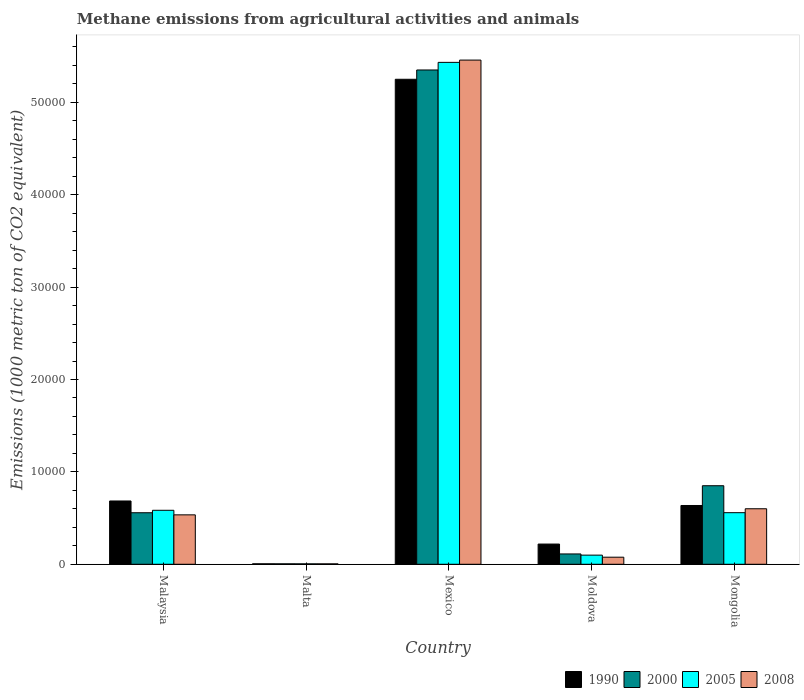Are the number of bars per tick equal to the number of legend labels?
Your answer should be very brief. Yes. Are the number of bars on each tick of the X-axis equal?
Your response must be concise. Yes. What is the label of the 3rd group of bars from the left?
Make the answer very short. Mexico. In how many cases, is the number of bars for a given country not equal to the number of legend labels?
Your response must be concise. 0. What is the amount of methane emitted in 2005 in Malaysia?
Offer a very short reply. 5844. Across all countries, what is the maximum amount of methane emitted in 2008?
Your answer should be compact. 5.46e+04. Across all countries, what is the minimum amount of methane emitted in 2005?
Offer a terse response. 48.2. In which country was the amount of methane emitted in 2005 minimum?
Your response must be concise. Malta. What is the total amount of methane emitted in 1990 in the graph?
Make the answer very short. 6.80e+04. What is the difference between the amount of methane emitted in 1990 in Mexico and that in Moldova?
Offer a very short reply. 5.03e+04. What is the difference between the amount of methane emitted in 2008 in Malaysia and the amount of methane emitted in 2005 in Moldova?
Ensure brevity in your answer.  4360. What is the average amount of methane emitted in 1990 per country?
Your answer should be compact. 1.36e+04. What is the difference between the amount of methane emitted of/in 2008 and amount of methane emitted of/in 2005 in Moldova?
Give a very brief answer. -223.2. What is the ratio of the amount of methane emitted in 2005 in Moldova to that in Mongolia?
Your response must be concise. 0.18. Is the amount of methane emitted in 2008 in Malta less than that in Mexico?
Ensure brevity in your answer.  Yes. What is the difference between the highest and the second highest amount of methane emitted in 2000?
Provide a short and direct response. 4.79e+04. What is the difference between the highest and the lowest amount of methane emitted in 2008?
Offer a terse response. 5.45e+04. Is the sum of the amount of methane emitted in 2005 in Mexico and Moldova greater than the maximum amount of methane emitted in 2000 across all countries?
Give a very brief answer. Yes. What does the 4th bar from the left in Malaysia represents?
Make the answer very short. 2008. Is it the case that in every country, the sum of the amount of methane emitted in 2000 and amount of methane emitted in 2008 is greater than the amount of methane emitted in 1990?
Give a very brief answer. No. Are the values on the major ticks of Y-axis written in scientific E-notation?
Offer a terse response. No. Does the graph contain any zero values?
Offer a terse response. No. Does the graph contain grids?
Your response must be concise. No. How many legend labels are there?
Provide a short and direct response. 4. What is the title of the graph?
Ensure brevity in your answer.  Methane emissions from agricultural activities and animals. What is the label or title of the X-axis?
Your answer should be compact. Country. What is the label or title of the Y-axis?
Ensure brevity in your answer.  Emissions (1000 metric ton of CO2 equivalent). What is the Emissions (1000 metric ton of CO2 equivalent) of 1990 in Malaysia?
Keep it short and to the point. 6851.5. What is the Emissions (1000 metric ton of CO2 equivalent) of 2000 in Malaysia?
Provide a short and direct response. 5579.2. What is the Emissions (1000 metric ton of CO2 equivalent) of 2005 in Malaysia?
Give a very brief answer. 5844. What is the Emissions (1000 metric ton of CO2 equivalent) of 2008 in Malaysia?
Keep it short and to the point. 5350.3. What is the Emissions (1000 metric ton of CO2 equivalent) in 1990 in Malta?
Offer a terse response. 50.9. What is the Emissions (1000 metric ton of CO2 equivalent) in 2000 in Malta?
Give a very brief answer. 50.6. What is the Emissions (1000 metric ton of CO2 equivalent) in 2005 in Malta?
Your response must be concise. 48.2. What is the Emissions (1000 metric ton of CO2 equivalent) of 2008 in Malta?
Your answer should be compact. 46.9. What is the Emissions (1000 metric ton of CO2 equivalent) of 1990 in Mexico?
Your answer should be compact. 5.25e+04. What is the Emissions (1000 metric ton of CO2 equivalent) in 2000 in Mexico?
Give a very brief answer. 5.35e+04. What is the Emissions (1000 metric ton of CO2 equivalent) in 2005 in Mexico?
Keep it short and to the point. 5.43e+04. What is the Emissions (1000 metric ton of CO2 equivalent) in 2008 in Mexico?
Your answer should be very brief. 5.46e+04. What is the Emissions (1000 metric ton of CO2 equivalent) in 1990 in Moldova?
Your answer should be compact. 2188.8. What is the Emissions (1000 metric ton of CO2 equivalent) in 2000 in Moldova?
Provide a succinct answer. 1119.3. What is the Emissions (1000 metric ton of CO2 equivalent) of 2005 in Moldova?
Make the answer very short. 990.3. What is the Emissions (1000 metric ton of CO2 equivalent) of 2008 in Moldova?
Offer a terse response. 767.1. What is the Emissions (1000 metric ton of CO2 equivalent) in 1990 in Mongolia?
Provide a succinct answer. 6363.5. What is the Emissions (1000 metric ton of CO2 equivalent) of 2000 in Mongolia?
Keep it short and to the point. 8502.3. What is the Emissions (1000 metric ton of CO2 equivalent) of 2005 in Mongolia?
Offer a very short reply. 5584.9. What is the Emissions (1000 metric ton of CO2 equivalent) in 2008 in Mongolia?
Your response must be concise. 6009.3. Across all countries, what is the maximum Emissions (1000 metric ton of CO2 equivalent) in 1990?
Offer a terse response. 5.25e+04. Across all countries, what is the maximum Emissions (1000 metric ton of CO2 equivalent) in 2000?
Offer a terse response. 5.35e+04. Across all countries, what is the maximum Emissions (1000 metric ton of CO2 equivalent) in 2005?
Your answer should be very brief. 5.43e+04. Across all countries, what is the maximum Emissions (1000 metric ton of CO2 equivalent) of 2008?
Your answer should be very brief. 5.46e+04. Across all countries, what is the minimum Emissions (1000 metric ton of CO2 equivalent) of 1990?
Provide a short and direct response. 50.9. Across all countries, what is the minimum Emissions (1000 metric ton of CO2 equivalent) of 2000?
Offer a very short reply. 50.6. Across all countries, what is the minimum Emissions (1000 metric ton of CO2 equivalent) in 2005?
Your response must be concise. 48.2. Across all countries, what is the minimum Emissions (1000 metric ton of CO2 equivalent) in 2008?
Make the answer very short. 46.9. What is the total Emissions (1000 metric ton of CO2 equivalent) of 1990 in the graph?
Provide a short and direct response. 6.80e+04. What is the total Emissions (1000 metric ton of CO2 equivalent) of 2000 in the graph?
Your response must be concise. 6.88e+04. What is the total Emissions (1000 metric ton of CO2 equivalent) in 2005 in the graph?
Make the answer very short. 6.68e+04. What is the total Emissions (1000 metric ton of CO2 equivalent) of 2008 in the graph?
Provide a short and direct response. 6.67e+04. What is the difference between the Emissions (1000 metric ton of CO2 equivalent) in 1990 in Malaysia and that in Malta?
Make the answer very short. 6800.6. What is the difference between the Emissions (1000 metric ton of CO2 equivalent) of 2000 in Malaysia and that in Malta?
Make the answer very short. 5528.6. What is the difference between the Emissions (1000 metric ton of CO2 equivalent) in 2005 in Malaysia and that in Malta?
Provide a short and direct response. 5795.8. What is the difference between the Emissions (1000 metric ton of CO2 equivalent) in 2008 in Malaysia and that in Malta?
Offer a terse response. 5303.4. What is the difference between the Emissions (1000 metric ton of CO2 equivalent) of 1990 in Malaysia and that in Mexico?
Offer a terse response. -4.56e+04. What is the difference between the Emissions (1000 metric ton of CO2 equivalent) of 2000 in Malaysia and that in Mexico?
Give a very brief answer. -4.79e+04. What is the difference between the Emissions (1000 metric ton of CO2 equivalent) in 2005 in Malaysia and that in Mexico?
Ensure brevity in your answer.  -4.85e+04. What is the difference between the Emissions (1000 metric ton of CO2 equivalent) of 2008 in Malaysia and that in Mexico?
Offer a very short reply. -4.92e+04. What is the difference between the Emissions (1000 metric ton of CO2 equivalent) of 1990 in Malaysia and that in Moldova?
Provide a short and direct response. 4662.7. What is the difference between the Emissions (1000 metric ton of CO2 equivalent) in 2000 in Malaysia and that in Moldova?
Offer a very short reply. 4459.9. What is the difference between the Emissions (1000 metric ton of CO2 equivalent) in 2005 in Malaysia and that in Moldova?
Keep it short and to the point. 4853.7. What is the difference between the Emissions (1000 metric ton of CO2 equivalent) in 2008 in Malaysia and that in Moldova?
Give a very brief answer. 4583.2. What is the difference between the Emissions (1000 metric ton of CO2 equivalent) of 1990 in Malaysia and that in Mongolia?
Provide a succinct answer. 488. What is the difference between the Emissions (1000 metric ton of CO2 equivalent) of 2000 in Malaysia and that in Mongolia?
Offer a terse response. -2923.1. What is the difference between the Emissions (1000 metric ton of CO2 equivalent) of 2005 in Malaysia and that in Mongolia?
Your answer should be very brief. 259.1. What is the difference between the Emissions (1000 metric ton of CO2 equivalent) in 2008 in Malaysia and that in Mongolia?
Ensure brevity in your answer.  -659. What is the difference between the Emissions (1000 metric ton of CO2 equivalent) of 1990 in Malta and that in Mexico?
Keep it short and to the point. -5.24e+04. What is the difference between the Emissions (1000 metric ton of CO2 equivalent) of 2000 in Malta and that in Mexico?
Ensure brevity in your answer.  -5.35e+04. What is the difference between the Emissions (1000 metric ton of CO2 equivalent) of 2005 in Malta and that in Mexico?
Make the answer very short. -5.43e+04. What is the difference between the Emissions (1000 metric ton of CO2 equivalent) in 2008 in Malta and that in Mexico?
Offer a very short reply. -5.45e+04. What is the difference between the Emissions (1000 metric ton of CO2 equivalent) in 1990 in Malta and that in Moldova?
Make the answer very short. -2137.9. What is the difference between the Emissions (1000 metric ton of CO2 equivalent) of 2000 in Malta and that in Moldova?
Offer a terse response. -1068.7. What is the difference between the Emissions (1000 metric ton of CO2 equivalent) of 2005 in Malta and that in Moldova?
Provide a succinct answer. -942.1. What is the difference between the Emissions (1000 metric ton of CO2 equivalent) of 2008 in Malta and that in Moldova?
Your answer should be very brief. -720.2. What is the difference between the Emissions (1000 metric ton of CO2 equivalent) in 1990 in Malta and that in Mongolia?
Ensure brevity in your answer.  -6312.6. What is the difference between the Emissions (1000 metric ton of CO2 equivalent) of 2000 in Malta and that in Mongolia?
Provide a short and direct response. -8451.7. What is the difference between the Emissions (1000 metric ton of CO2 equivalent) of 2005 in Malta and that in Mongolia?
Offer a terse response. -5536.7. What is the difference between the Emissions (1000 metric ton of CO2 equivalent) in 2008 in Malta and that in Mongolia?
Make the answer very short. -5962.4. What is the difference between the Emissions (1000 metric ton of CO2 equivalent) of 1990 in Mexico and that in Moldova?
Give a very brief answer. 5.03e+04. What is the difference between the Emissions (1000 metric ton of CO2 equivalent) in 2000 in Mexico and that in Moldova?
Offer a terse response. 5.24e+04. What is the difference between the Emissions (1000 metric ton of CO2 equivalent) of 2005 in Mexico and that in Moldova?
Provide a short and direct response. 5.33e+04. What is the difference between the Emissions (1000 metric ton of CO2 equivalent) in 2008 in Mexico and that in Moldova?
Provide a short and direct response. 5.38e+04. What is the difference between the Emissions (1000 metric ton of CO2 equivalent) of 1990 in Mexico and that in Mongolia?
Ensure brevity in your answer.  4.61e+04. What is the difference between the Emissions (1000 metric ton of CO2 equivalent) of 2000 in Mexico and that in Mongolia?
Your response must be concise. 4.50e+04. What is the difference between the Emissions (1000 metric ton of CO2 equivalent) of 2005 in Mexico and that in Mongolia?
Offer a terse response. 4.87e+04. What is the difference between the Emissions (1000 metric ton of CO2 equivalent) of 2008 in Mexico and that in Mongolia?
Your answer should be compact. 4.86e+04. What is the difference between the Emissions (1000 metric ton of CO2 equivalent) of 1990 in Moldova and that in Mongolia?
Make the answer very short. -4174.7. What is the difference between the Emissions (1000 metric ton of CO2 equivalent) of 2000 in Moldova and that in Mongolia?
Provide a short and direct response. -7383. What is the difference between the Emissions (1000 metric ton of CO2 equivalent) in 2005 in Moldova and that in Mongolia?
Make the answer very short. -4594.6. What is the difference between the Emissions (1000 metric ton of CO2 equivalent) in 2008 in Moldova and that in Mongolia?
Make the answer very short. -5242.2. What is the difference between the Emissions (1000 metric ton of CO2 equivalent) in 1990 in Malaysia and the Emissions (1000 metric ton of CO2 equivalent) in 2000 in Malta?
Offer a very short reply. 6800.9. What is the difference between the Emissions (1000 metric ton of CO2 equivalent) of 1990 in Malaysia and the Emissions (1000 metric ton of CO2 equivalent) of 2005 in Malta?
Offer a terse response. 6803.3. What is the difference between the Emissions (1000 metric ton of CO2 equivalent) of 1990 in Malaysia and the Emissions (1000 metric ton of CO2 equivalent) of 2008 in Malta?
Offer a very short reply. 6804.6. What is the difference between the Emissions (1000 metric ton of CO2 equivalent) in 2000 in Malaysia and the Emissions (1000 metric ton of CO2 equivalent) in 2005 in Malta?
Your answer should be very brief. 5531. What is the difference between the Emissions (1000 metric ton of CO2 equivalent) in 2000 in Malaysia and the Emissions (1000 metric ton of CO2 equivalent) in 2008 in Malta?
Your answer should be very brief. 5532.3. What is the difference between the Emissions (1000 metric ton of CO2 equivalent) in 2005 in Malaysia and the Emissions (1000 metric ton of CO2 equivalent) in 2008 in Malta?
Keep it short and to the point. 5797.1. What is the difference between the Emissions (1000 metric ton of CO2 equivalent) in 1990 in Malaysia and the Emissions (1000 metric ton of CO2 equivalent) in 2000 in Mexico?
Provide a succinct answer. -4.67e+04. What is the difference between the Emissions (1000 metric ton of CO2 equivalent) of 1990 in Malaysia and the Emissions (1000 metric ton of CO2 equivalent) of 2005 in Mexico?
Give a very brief answer. -4.75e+04. What is the difference between the Emissions (1000 metric ton of CO2 equivalent) of 1990 in Malaysia and the Emissions (1000 metric ton of CO2 equivalent) of 2008 in Mexico?
Your response must be concise. -4.77e+04. What is the difference between the Emissions (1000 metric ton of CO2 equivalent) of 2000 in Malaysia and the Emissions (1000 metric ton of CO2 equivalent) of 2005 in Mexico?
Your response must be concise. -4.88e+04. What is the difference between the Emissions (1000 metric ton of CO2 equivalent) in 2000 in Malaysia and the Emissions (1000 metric ton of CO2 equivalent) in 2008 in Mexico?
Keep it short and to the point. -4.90e+04. What is the difference between the Emissions (1000 metric ton of CO2 equivalent) of 2005 in Malaysia and the Emissions (1000 metric ton of CO2 equivalent) of 2008 in Mexico?
Give a very brief answer. -4.87e+04. What is the difference between the Emissions (1000 metric ton of CO2 equivalent) in 1990 in Malaysia and the Emissions (1000 metric ton of CO2 equivalent) in 2000 in Moldova?
Your answer should be very brief. 5732.2. What is the difference between the Emissions (1000 metric ton of CO2 equivalent) in 1990 in Malaysia and the Emissions (1000 metric ton of CO2 equivalent) in 2005 in Moldova?
Your answer should be compact. 5861.2. What is the difference between the Emissions (1000 metric ton of CO2 equivalent) of 1990 in Malaysia and the Emissions (1000 metric ton of CO2 equivalent) of 2008 in Moldova?
Keep it short and to the point. 6084.4. What is the difference between the Emissions (1000 metric ton of CO2 equivalent) of 2000 in Malaysia and the Emissions (1000 metric ton of CO2 equivalent) of 2005 in Moldova?
Your answer should be very brief. 4588.9. What is the difference between the Emissions (1000 metric ton of CO2 equivalent) of 2000 in Malaysia and the Emissions (1000 metric ton of CO2 equivalent) of 2008 in Moldova?
Provide a short and direct response. 4812.1. What is the difference between the Emissions (1000 metric ton of CO2 equivalent) in 2005 in Malaysia and the Emissions (1000 metric ton of CO2 equivalent) in 2008 in Moldova?
Offer a very short reply. 5076.9. What is the difference between the Emissions (1000 metric ton of CO2 equivalent) in 1990 in Malaysia and the Emissions (1000 metric ton of CO2 equivalent) in 2000 in Mongolia?
Provide a short and direct response. -1650.8. What is the difference between the Emissions (1000 metric ton of CO2 equivalent) in 1990 in Malaysia and the Emissions (1000 metric ton of CO2 equivalent) in 2005 in Mongolia?
Your answer should be compact. 1266.6. What is the difference between the Emissions (1000 metric ton of CO2 equivalent) of 1990 in Malaysia and the Emissions (1000 metric ton of CO2 equivalent) of 2008 in Mongolia?
Ensure brevity in your answer.  842.2. What is the difference between the Emissions (1000 metric ton of CO2 equivalent) in 2000 in Malaysia and the Emissions (1000 metric ton of CO2 equivalent) in 2005 in Mongolia?
Your answer should be compact. -5.7. What is the difference between the Emissions (1000 metric ton of CO2 equivalent) of 2000 in Malaysia and the Emissions (1000 metric ton of CO2 equivalent) of 2008 in Mongolia?
Your response must be concise. -430.1. What is the difference between the Emissions (1000 metric ton of CO2 equivalent) in 2005 in Malaysia and the Emissions (1000 metric ton of CO2 equivalent) in 2008 in Mongolia?
Provide a short and direct response. -165.3. What is the difference between the Emissions (1000 metric ton of CO2 equivalent) of 1990 in Malta and the Emissions (1000 metric ton of CO2 equivalent) of 2000 in Mexico?
Make the answer very short. -5.35e+04. What is the difference between the Emissions (1000 metric ton of CO2 equivalent) in 1990 in Malta and the Emissions (1000 metric ton of CO2 equivalent) in 2005 in Mexico?
Make the answer very short. -5.43e+04. What is the difference between the Emissions (1000 metric ton of CO2 equivalent) of 1990 in Malta and the Emissions (1000 metric ton of CO2 equivalent) of 2008 in Mexico?
Your response must be concise. -5.45e+04. What is the difference between the Emissions (1000 metric ton of CO2 equivalent) in 2000 in Malta and the Emissions (1000 metric ton of CO2 equivalent) in 2005 in Mexico?
Provide a succinct answer. -5.43e+04. What is the difference between the Emissions (1000 metric ton of CO2 equivalent) of 2000 in Malta and the Emissions (1000 metric ton of CO2 equivalent) of 2008 in Mexico?
Make the answer very short. -5.45e+04. What is the difference between the Emissions (1000 metric ton of CO2 equivalent) in 2005 in Malta and the Emissions (1000 metric ton of CO2 equivalent) in 2008 in Mexico?
Your answer should be compact. -5.45e+04. What is the difference between the Emissions (1000 metric ton of CO2 equivalent) in 1990 in Malta and the Emissions (1000 metric ton of CO2 equivalent) in 2000 in Moldova?
Make the answer very short. -1068.4. What is the difference between the Emissions (1000 metric ton of CO2 equivalent) in 1990 in Malta and the Emissions (1000 metric ton of CO2 equivalent) in 2005 in Moldova?
Your answer should be very brief. -939.4. What is the difference between the Emissions (1000 metric ton of CO2 equivalent) in 1990 in Malta and the Emissions (1000 metric ton of CO2 equivalent) in 2008 in Moldova?
Provide a short and direct response. -716.2. What is the difference between the Emissions (1000 metric ton of CO2 equivalent) in 2000 in Malta and the Emissions (1000 metric ton of CO2 equivalent) in 2005 in Moldova?
Your answer should be very brief. -939.7. What is the difference between the Emissions (1000 metric ton of CO2 equivalent) in 2000 in Malta and the Emissions (1000 metric ton of CO2 equivalent) in 2008 in Moldova?
Provide a succinct answer. -716.5. What is the difference between the Emissions (1000 metric ton of CO2 equivalent) in 2005 in Malta and the Emissions (1000 metric ton of CO2 equivalent) in 2008 in Moldova?
Provide a short and direct response. -718.9. What is the difference between the Emissions (1000 metric ton of CO2 equivalent) of 1990 in Malta and the Emissions (1000 metric ton of CO2 equivalent) of 2000 in Mongolia?
Give a very brief answer. -8451.4. What is the difference between the Emissions (1000 metric ton of CO2 equivalent) of 1990 in Malta and the Emissions (1000 metric ton of CO2 equivalent) of 2005 in Mongolia?
Keep it short and to the point. -5534. What is the difference between the Emissions (1000 metric ton of CO2 equivalent) of 1990 in Malta and the Emissions (1000 metric ton of CO2 equivalent) of 2008 in Mongolia?
Give a very brief answer. -5958.4. What is the difference between the Emissions (1000 metric ton of CO2 equivalent) in 2000 in Malta and the Emissions (1000 metric ton of CO2 equivalent) in 2005 in Mongolia?
Provide a short and direct response. -5534.3. What is the difference between the Emissions (1000 metric ton of CO2 equivalent) in 2000 in Malta and the Emissions (1000 metric ton of CO2 equivalent) in 2008 in Mongolia?
Give a very brief answer. -5958.7. What is the difference between the Emissions (1000 metric ton of CO2 equivalent) in 2005 in Malta and the Emissions (1000 metric ton of CO2 equivalent) in 2008 in Mongolia?
Offer a very short reply. -5961.1. What is the difference between the Emissions (1000 metric ton of CO2 equivalent) in 1990 in Mexico and the Emissions (1000 metric ton of CO2 equivalent) in 2000 in Moldova?
Your answer should be compact. 5.14e+04. What is the difference between the Emissions (1000 metric ton of CO2 equivalent) of 1990 in Mexico and the Emissions (1000 metric ton of CO2 equivalent) of 2005 in Moldova?
Provide a short and direct response. 5.15e+04. What is the difference between the Emissions (1000 metric ton of CO2 equivalent) of 1990 in Mexico and the Emissions (1000 metric ton of CO2 equivalent) of 2008 in Moldova?
Your response must be concise. 5.17e+04. What is the difference between the Emissions (1000 metric ton of CO2 equivalent) in 2000 in Mexico and the Emissions (1000 metric ton of CO2 equivalent) in 2005 in Moldova?
Give a very brief answer. 5.25e+04. What is the difference between the Emissions (1000 metric ton of CO2 equivalent) in 2000 in Mexico and the Emissions (1000 metric ton of CO2 equivalent) in 2008 in Moldova?
Your answer should be very brief. 5.27e+04. What is the difference between the Emissions (1000 metric ton of CO2 equivalent) in 2005 in Mexico and the Emissions (1000 metric ton of CO2 equivalent) in 2008 in Moldova?
Offer a terse response. 5.36e+04. What is the difference between the Emissions (1000 metric ton of CO2 equivalent) in 1990 in Mexico and the Emissions (1000 metric ton of CO2 equivalent) in 2000 in Mongolia?
Give a very brief answer. 4.40e+04. What is the difference between the Emissions (1000 metric ton of CO2 equivalent) in 1990 in Mexico and the Emissions (1000 metric ton of CO2 equivalent) in 2005 in Mongolia?
Your answer should be compact. 4.69e+04. What is the difference between the Emissions (1000 metric ton of CO2 equivalent) of 1990 in Mexico and the Emissions (1000 metric ton of CO2 equivalent) of 2008 in Mongolia?
Make the answer very short. 4.65e+04. What is the difference between the Emissions (1000 metric ton of CO2 equivalent) in 2000 in Mexico and the Emissions (1000 metric ton of CO2 equivalent) in 2005 in Mongolia?
Ensure brevity in your answer.  4.79e+04. What is the difference between the Emissions (1000 metric ton of CO2 equivalent) in 2000 in Mexico and the Emissions (1000 metric ton of CO2 equivalent) in 2008 in Mongolia?
Offer a very short reply. 4.75e+04. What is the difference between the Emissions (1000 metric ton of CO2 equivalent) of 2005 in Mexico and the Emissions (1000 metric ton of CO2 equivalent) of 2008 in Mongolia?
Your answer should be compact. 4.83e+04. What is the difference between the Emissions (1000 metric ton of CO2 equivalent) in 1990 in Moldova and the Emissions (1000 metric ton of CO2 equivalent) in 2000 in Mongolia?
Your answer should be very brief. -6313.5. What is the difference between the Emissions (1000 metric ton of CO2 equivalent) in 1990 in Moldova and the Emissions (1000 metric ton of CO2 equivalent) in 2005 in Mongolia?
Make the answer very short. -3396.1. What is the difference between the Emissions (1000 metric ton of CO2 equivalent) in 1990 in Moldova and the Emissions (1000 metric ton of CO2 equivalent) in 2008 in Mongolia?
Offer a terse response. -3820.5. What is the difference between the Emissions (1000 metric ton of CO2 equivalent) in 2000 in Moldova and the Emissions (1000 metric ton of CO2 equivalent) in 2005 in Mongolia?
Your response must be concise. -4465.6. What is the difference between the Emissions (1000 metric ton of CO2 equivalent) of 2000 in Moldova and the Emissions (1000 metric ton of CO2 equivalent) of 2008 in Mongolia?
Offer a very short reply. -4890. What is the difference between the Emissions (1000 metric ton of CO2 equivalent) in 2005 in Moldova and the Emissions (1000 metric ton of CO2 equivalent) in 2008 in Mongolia?
Provide a succinct answer. -5019. What is the average Emissions (1000 metric ton of CO2 equivalent) of 1990 per country?
Ensure brevity in your answer.  1.36e+04. What is the average Emissions (1000 metric ton of CO2 equivalent) of 2000 per country?
Your answer should be compact. 1.38e+04. What is the average Emissions (1000 metric ton of CO2 equivalent) of 2005 per country?
Your answer should be very brief. 1.34e+04. What is the average Emissions (1000 metric ton of CO2 equivalent) of 2008 per country?
Provide a succinct answer. 1.33e+04. What is the difference between the Emissions (1000 metric ton of CO2 equivalent) of 1990 and Emissions (1000 metric ton of CO2 equivalent) of 2000 in Malaysia?
Your answer should be very brief. 1272.3. What is the difference between the Emissions (1000 metric ton of CO2 equivalent) of 1990 and Emissions (1000 metric ton of CO2 equivalent) of 2005 in Malaysia?
Provide a succinct answer. 1007.5. What is the difference between the Emissions (1000 metric ton of CO2 equivalent) in 1990 and Emissions (1000 metric ton of CO2 equivalent) in 2008 in Malaysia?
Your answer should be compact. 1501.2. What is the difference between the Emissions (1000 metric ton of CO2 equivalent) in 2000 and Emissions (1000 metric ton of CO2 equivalent) in 2005 in Malaysia?
Ensure brevity in your answer.  -264.8. What is the difference between the Emissions (1000 metric ton of CO2 equivalent) in 2000 and Emissions (1000 metric ton of CO2 equivalent) in 2008 in Malaysia?
Make the answer very short. 228.9. What is the difference between the Emissions (1000 metric ton of CO2 equivalent) of 2005 and Emissions (1000 metric ton of CO2 equivalent) of 2008 in Malaysia?
Offer a terse response. 493.7. What is the difference between the Emissions (1000 metric ton of CO2 equivalent) of 2000 and Emissions (1000 metric ton of CO2 equivalent) of 2005 in Malta?
Provide a succinct answer. 2.4. What is the difference between the Emissions (1000 metric ton of CO2 equivalent) in 2000 and Emissions (1000 metric ton of CO2 equivalent) in 2008 in Malta?
Your answer should be very brief. 3.7. What is the difference between the Emissions (1000 metric ton of CO2 equivalent) of 2005 and Emissions (1000 metric ton of CO2 equivalent) of 2008 in Malta?
Keep it short and to the point. 1.3. What is the difference between the Emissions (1000 metric ton of CO2 equivalent) in 1990 and Emissions (1000 metric ton of CO2 equivalent) in 2000 in Mexico?
Offer a very short reply. -1007.1. What is the difference between the Emissions (1000 metric ton of CO2 equivalent) in 1990 and Emissions (1000 metric ton of CO2 equivalent) in 2005 in Mexico?
Provide a short and direct response. -1831.1. What is the difference between the Emissions (1000 metric ton of CO2 equivalent) in 1990 and Emissions (1000 metric ton of CO2 equivalent) in 2008 in Mexico?
Offer a terse response. -2077.8. What is the difference between the Emissions (1000 metric ton of CO2 equivalent) of 2000 and Emissions (1000 metric ton of CO2 equivalent) of 2005 in Mexico?
Make the answer very short. -824. What is the difference between the Emissions (1000 metric ton of CO2 equivalent) in 2000 and Emissions (1000 metric ton of CO2 equivalent) in 2008 in Mexico?
Offer a very short reply. -1070.7. What is the difference between the Emissions (1000 metric ton of CO2 equivalent) of 2005 and Emissions (1000 metric ton of CO2 equivalent) of 2008 in Mexico?
Your answer should be very brief. -246.7. What is the difference between the Emissions (1000 metric ton of CO2 equivalent) in 1990 and Emissions (1000 metric ton of CO2 equivalent) in 2000 in Moldova?
Your answer should be compact. 1069.5. What is the difference between the Emissions (1000 metric ton of CO2 equivalent) of 1990 and Emissions (1000 metric ton of CO2 equivalent) of 2005 in Moldova?
Your answer should be very brief. 1198.5. What is the difference between the Emissions (1000 metric ton of CO2 equivalent) of 1990 and Emissions (1000 metric ton of CO2 equivalent) of 2008 in Moldova?
Give a very brief answer. 1421.7. What is the difference between the Emissions (1000 metric ton of CO2 equivalent) in 2000 and Emissions (1000 metric ton of CO2 equivalent) in 2005 in Moldova?
Provide a succinct answer. 129. What is the difference between the Emissions (1000 metric ton of CO2 equivalent) of 2000 and Emissions (1000 metric ton of CO2 equivalent) of 2008 in Moldova?
Your answer should be very brief. 352.2. What is the difference between the Emissions (1000 metric ton of CO2 equivalent) in 2005 and Emissions (1000 metric ton of CO2 equivalent) in 2008 in Moldova?
Provide a short and direct response. 223.2. What is the difference between the Emissions (1000 metric ton of CO2 equivalent) of 1990 and Emissions (1000 metric ton of CO2 equivalent) of 2000 in Mongolia?
Make the answer very short. -2138.8. What is the difference between the Emissions (1000 metric ton of CO2 equivalent) of 1990 and Emissions (1000 metric ton of CO2 equivalent) of 2005 in Mongolia?
Your answer should be compact. 778.6. What is the difference between the Emissions (1000 metric ton of CO2 equivalent) of 1990 and Emissions (1000 metric ton of CO2 equivalent) of 2008 in Mongolia?
Ensure brevity in your answer.  354.2. What is the difference between the Emissions (1000 metric ton of CO2 equivalent) of 2000 and Emissions (1000 metric ton of CO2 equivalent) of 2005 in Mongolia?
Ensure brevity in your answer.  2917.4. What is the difference between the Emissions (1000 metric ton of CO2 equivalent) in 2000 and Emissions (1000 metric ton of CO2 equivalent) in 2008 in Mongolia?
Make the answer very short. 2493. What is the difference between the Emissions (1000 metric ton of CO2 equivalent) of 2005 and Emissions (1000 metric ton of CO2 equivalent) of 2008 in Mongolia?
Offer a very short reply. -424.4. What is the ratio of the Emissions (1000 metric ton of CO2 equivalent) in 1990 in Malaysia to that in Malta?
Offer a terse response. 134.61. What is the ratio of the Emissions (1000 metric ton of CO2 equivalent) of 2000 in Malaysia to that in Malta?
Give a very brief answer. 110.26. What is the ratio of the Emissions (1000 metric ton of CO2 equivalent) of 2005 in Malaysia to that in Malta?
Provide a short and direct response. 121.24. What is the ratio of the Emissions (1000 metric ton of CO2 equivalent) in 2008 in Malaysia to that in Malta?
Your answer should be very brief. 114.08. What is the ratio of the Emissions (1000 metric ton of CO2 equivalent) of 1990 in Malaysia to that in Mexico?
Give a very brief answer. 0.13. What is the ratio of the Emissions (1000 metric ton of CO2 equivalent) in 2000 in Malaysia to that in Mexico?
Give a very brief answer. 0.1. What is the ratio of the Emissions (1000 metric ton of CO2 equivalent) in 2005 in Malaysia to that in Mexico?
Your response must be concise. 0.11. What is the ratio of the Emissions (1000 metric ton of CO2 equivalent) of 2008 in Malaysia to that in Mexico?
Keep it short and to the point. 0.1. What is the ratio of the Emissions (1000 metric ton of CO2 equivalent) of 1990 in Malaysia to that in Moldova?
Make the answer very short. 3.13. What is the ratio of the Emissions (1000 metric ton of CO2 equivalent) of 2000 in Malaysia to that in Moldova?
Offer a very short reply. 4.98. What is the ratio of the Emissions (1000 metric ton of CO2 equivalent) in 2005 in Malaysia to that in Moldova?
Provide a short and direct response. 5.9. What is the ratio of the Emissions (1000 metric ton of CO2 equivalent) of 2008 in Malaysia to that in Moldova?
Provide a short and direct response. 6.97. What is the ratio of the Emissions (1000 metric ton of CO2 equivalent) in 1990 in Malaysia to that in Mongolia?
Offer a terse response. 1.08. What is the ratio of the Emissions (1000 metric ton of CO2 equivalent) in 2000 in Malaysia to that in Mongolia?
Your answer should be very brief. 0.66. What is the ratio of the Emissions (1000 metric ton of CO2 equivalent) of 2005 in Malaysia to that in Mongolia?
Keep it short and to the point. 1.05. What is the ratio of the Emissions (1000 metric ton of CO2 equivalent) in 2008 in Malaysia to that in Mongolia?
Make the answer very short. 0.89. What is the ratio of the Emissions (1000 metric ton of CO2 equivalent) in 2000 in Malta to that in Mexico?
Offer a terse response. 0. What is the ratio of the Emissions (1000 metric ton of CO2 equivalent) in 2005 in Malta to that in Mexico?
Your response must be concise. 0. What is the ratio of the Emissions (1000 metric ton of CO2 equivalent) in 2008 in Malta to that in Mexico?
Offer a very short reply. 0. What is the ratio of the Emissions (1000 metric ton of CO2 equivalent) in 1990 in Malta to that in Moldova?
Your answer should be very brief. 0.02. What is the ratio of the Emissions (1000 metric ton of CO2 equivalent) in 2000 in Malta to that in Moldova?
Your answer should be very brief. 0.05. What is the ratio of the Emissions (1000 metric ton of CO2 equivalent) in 2005 in Malta to that in Moldova?
Offer a terse response. 0.05. What is the ratio of the Emissions (1000 metric ton of CO2 equivalent) in 2008 in Malta to that in Moldova?
Provide a short and direct response. 0.06. What is the ratio of the Emissions (1000 metric ton of CO2 equivalent) in 1990 in Malta to that in Mongolia?
Give a very brief answer. 0.01. What is the ratio of the Emissions (1000 metric ton of CO2 equivalent) in 2000 in Malta to that in Mongolia?
Give a very brief answer. 0.01. What is the ratio of the Emissions (1000 metric ton of CO2 equivalent) of 2005 in Malta to that in Mongolia?
Give a very brief answer. 0.01. What is the ratio of the Emissions (1000 metric ton of CO2 equivalent) in 2008 in Malta to that in Mongolia?
Give a very brief answer. 0.01. What is the ratio of the Emissions (1000 metric ton of CO2 equivalent) of 1990 in Mexico to that in Moldova?
Provide a short and direct response. 23.99. What is the ratio of the Emissions (1000 metric ton of CO2 equivalent) in 2000 in Mexico to that in Moldova?
Provide a succinct answer. 47.8. What is the ratio of the Emissions (1000 metric ton of CO2 equivalent) of 2005 in Mexico to that in Moldova?
Give a very brief answer. 54.86. What is the ratio of the Emissions (1000 metric ton of CO2 equivalent) of 2008 in Mexico to that in Moldova?
Make the answer very short. 71.15. What is the ratio of the Emissions (1000 metric ton of CO2 equivalent) of 1990 in Mexico to that in Mongolia?
Make the answer very short. 8.25. What is the ratio of the Emissions (1000 metric ton of CO2 equivalent) in 2000 in Mexico to that in Mongolia?
Keep it short and to the point. 6.29. What is the ratio of the Emissions (1000 metric ton of CO2 equivalent) in 2005 in Mexico to that in Mongolia?
Your response must be concise. 9.73. What is the ratio of the Emissions (1000 metric ton of CO2 equivalent) of 2008 in Mexico to that in Mongolia?
Provide a succinct answer. 9.08. What is the ratio of the Emissions (1000 metric ton of CO2 equivalent) in 1990 in Moldova to that in Mongolia?
Offer a terse response. 0.34. What is the ratio of the Emissions (1000 metric ton of CO2 equivalent) of 2000 in Moldova to that in Mongolia?
Give a very brief answer. 0.13. What is the ratio of the Emissions (1000 metric ton of CO2 equivalent) in 2005 in Moldova to that in Mongolia?
Provide a succinct answer. 0.18. What is the ratio of the Emissions (1000 metric ton of CO2 equivalent) in 2008 in Moldova to that in Mongolia?
Provide a short and direct response. 0.13. What is the difference between the highest and the second highest Emissions (1000 metric ton of CO2 equivalent) in 1990?
Provide a succinct answer. 4.56e+04. What is the difference between the highest and the second highest Emissions (1000 metric ton of CO2 equivalent) of 2000?
Your answer should be very brief. 4.50e+04. What is the difference between the highest and the second highest Emissions (1000 metric ton of CO2 equivalent) of 2005?
Make the answer very short. 4.85e+04. What is the difference between the highest and the second highest Emissions (1000 metric ton of CO2 equivalent) of 2008?
Offer a terse response. 4.86e+04. What is the difference between the highest and the lowest Emissions (1000 metric ton of CO2 equivalent) of 1990?
Make the answer very short. 5.24e+04. What is the difference between the highest and the lowest Emissions (1000 metric ton of CO2 equivalent) in 2000?
Provide a succinct answer. 5.35e+04. What is the difference between the highest and the lowest Emissions (1000 metric ton of CO2 equivalent) of 2005?
Keep it short and to the point. 5.43e+04. What is the difference between the highest and the lowest Emissions (1000 metric ton of CO2 equivalent) in 2008?
Provide a short and direct response. 5.45e+04. 